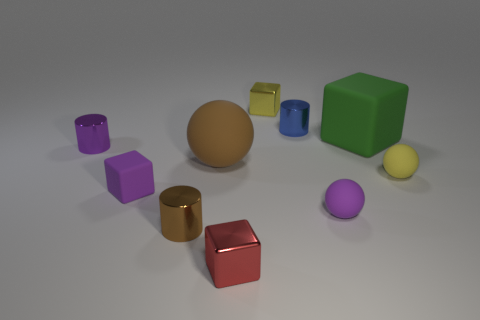There is a tiny cylinder that is the same color as the big matte ball; what is it made of?
Keep it short and to the point. Metal. What number of small green metal cubes are there?
Provide a short and direct response. 0. There is a matte object that is left of the brown cylinder; does it have the same size as the yellow cube?
Offer a very short reply. Yes. How many metal objects are either green objects or cubes?
Your answer should be very brief. 2. There is a cylinder that is to the left of the small brown metallic cylinder; what number of red objects are right of it?
Your answer should be compact. 1. There is a metallic object that is both behind the large brown rubber ball and in front of the small blue metal cylinder; what shape is it?
Make the answer very short. Cylinder. There is a small yellow thing in front of the tiny cube behind the rubber block that is to the right of the tiny blue object; what is it made of?
Ensure brevity in your answer.  Rubber. The cylinder that is the same color as the big matte ball is what size?
Offer a terse response. Small. What is the material of the tiny blue cylinder?
Make the answer very short. Metal. Do the large brown thing and the small purple thing that is to the right of the tiny brown shiny cylinder have the same material?
Give a very brief answer. Yes. 